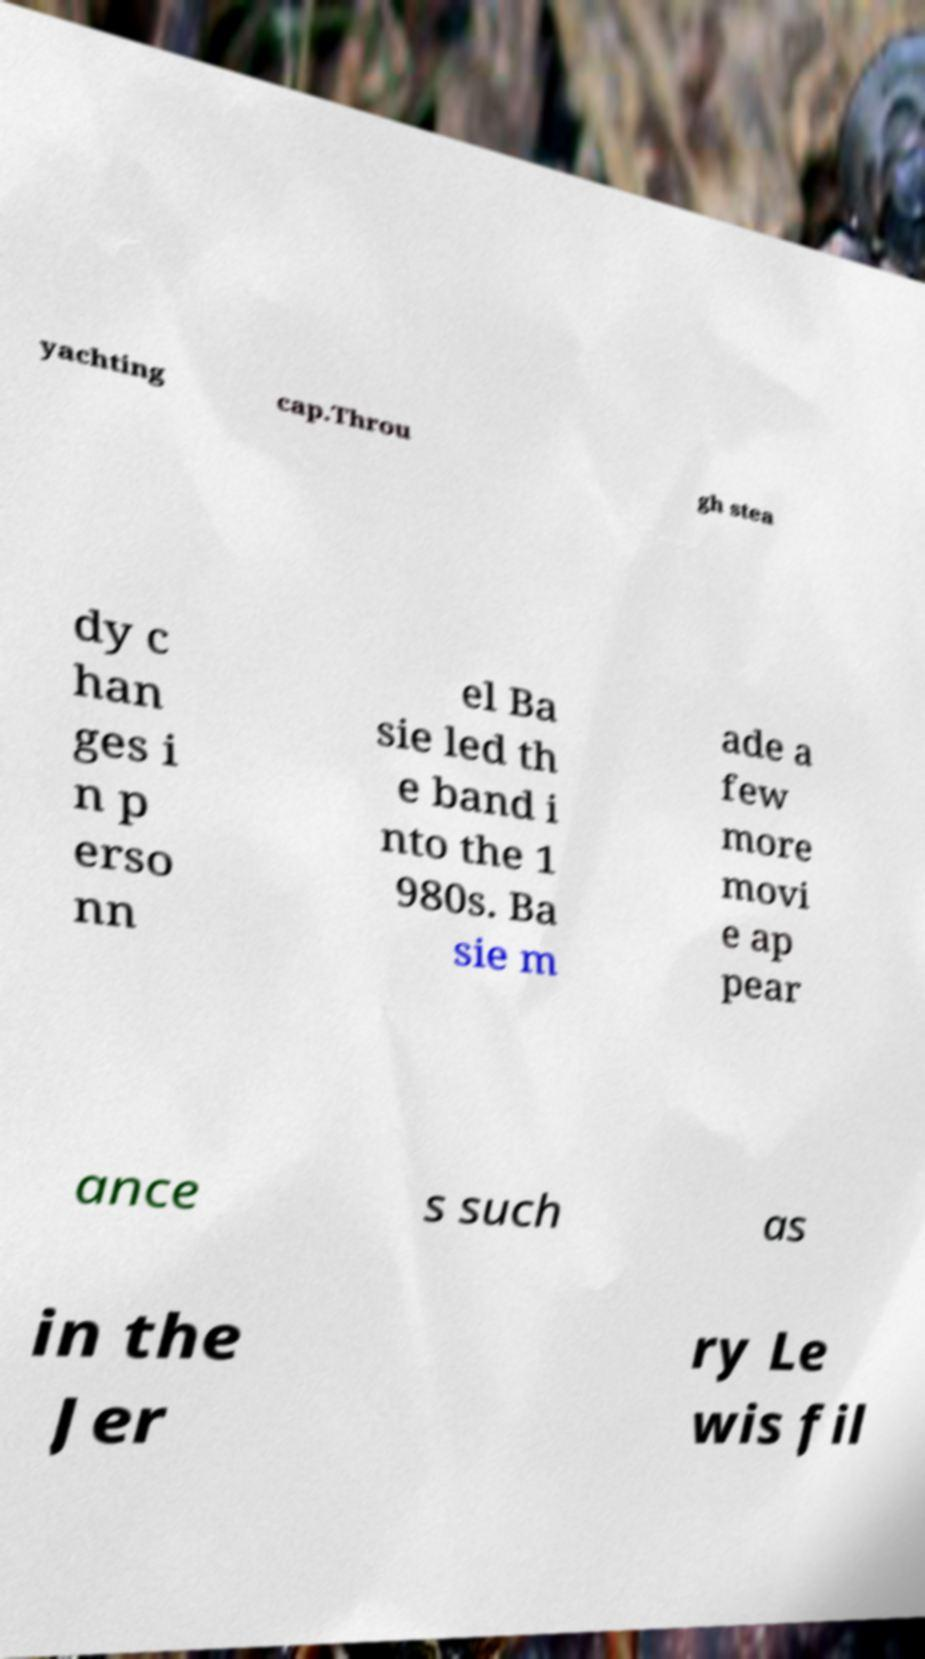Can you read and provide the text displayed in the image?This photo seems to have some interesting text. Can you extract and type it out for me? yachting cap.Throu gh stea dy c han ges i n p erso nn el Ba sie led th e band i nto the 1 980s. Ba sie m ade a few more movi e ap pear ance s such as in the Jer ry Le wis fil 